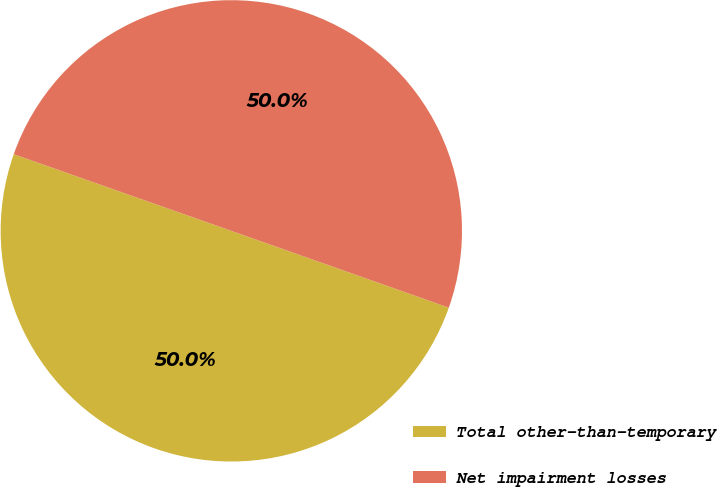<chart> <loc_0><loc_0><loc_500><loc_500><pie_chart><fcel>Total other-than-temporary<fcel>Net impairment losses<nl><fcel>49.99%<fcel>50.01%<nl></chart> 